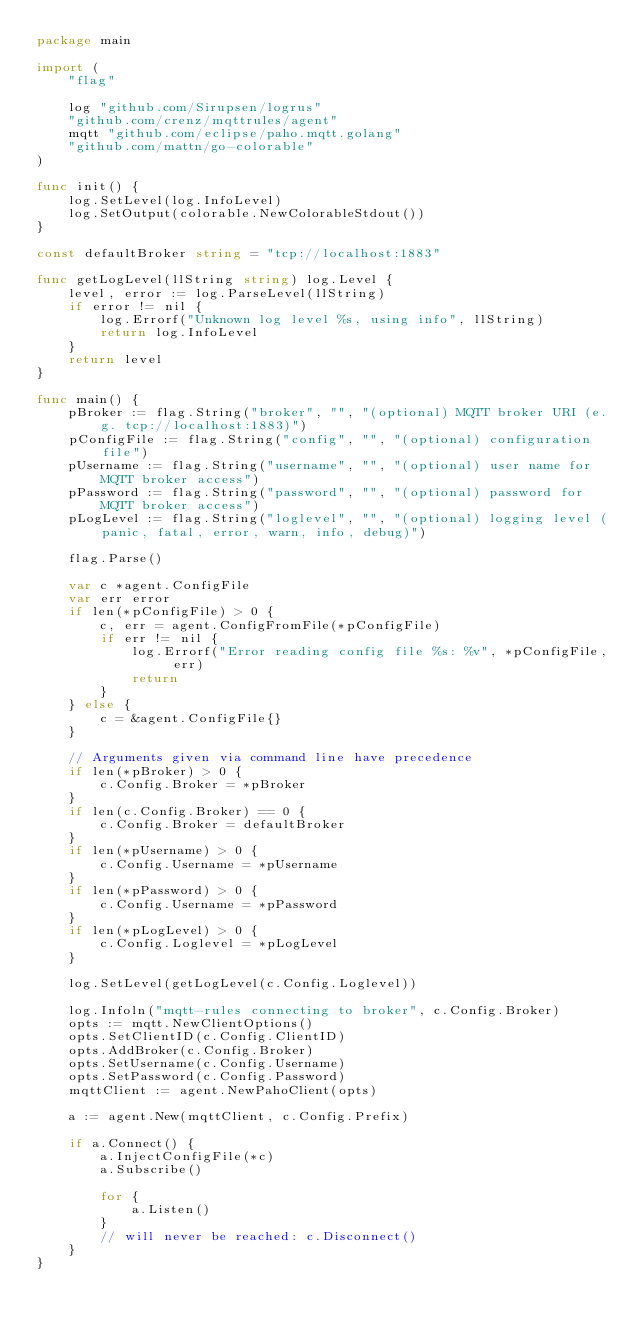<code> <loc_0><loc_0><loc_500><loc_500><_Go_>package main

import (
	"flag"

	log "github.com/Sirupsen/logrus"
	"github.com/crenz/mqttrules/agent"
	mqtt "github.com/eclipse/paho.mqtt.golang"
	"github.com/mattn/go-colorable"
)

func init() {
	log.SetLevel(log.InfoLevel)
	log.SetOutput(colorable.NewColorableStdout())
}

const defaultBroker string = "tcp://localhost:1883"

func getLogLevel(llString string) log.Level {
	level, error := log.ParseLevel(llString)
	if error != nil {
		log.Errorf("Unknown log level %s, using info", llString)
		return log.InfoLevel
	}
	return level
}

func main() {
	pBroker := flag.String("broker", "", "(optional) MQTT broker URI (e.g. tcp://localhost:1883)")
	pConfigFile := flag.String("config", "", "(optional) configuration file")
	pUsername := flag.String("username", "", "(optional) user name for MQTT broker access")
	pPassword := flag.String("password", "", "(optional) password for MQTT broker access")
	pLogLevel := flag.String("loglevel", "", "(optional) logging level (panic, fatal, error, warn, info, debug)")

	flag.Parse()

	var c *agent.ConfigFile
	var err error
	if len(*pConfigFile) > 0 {
		c, err = agent.ConfigFromFile(*pConfigFile)
		if err != nil {
			log.Errorf("Error reading config file %s: %v", *pConfigFile, err)
			return
		}
	} else {
		c = &agent.ConfigFile{}
	}

	// Arguments given via command line have precedence
	if len(*pBroker) > 0 {
		c.Config.Broker = *pBroker
	}
	if len(c.Config.Broker) == 0 {
		c.Config.Broker = defaultBroker
	}
	if len(*pUsername) > 0 {
		c.Config.Username = *pUsername
	}
	if len(*pPassword) > 0 {
		c.Config.Username = *pPassword
	}
	if len(*pLogLevel) > 0 {
		c.Config.Loglevel = *pLogLevel
	}

	log.SetLevel(getLogLevel(c.Config.Loglevel))

	log.Infoln("mqtt-rules connecting to broker", c.Config.Broker)
	opts := mqtt.NewClientOptions()
	opts.SetClientID(c.Config.ClientID)
	opts.AddBroker(c.Config.Broker)
	opts.SetUsername(c.Config.Username)
	opts.SetPassword(c.Config.Password)
	mqttClient := agent.NewPahoClient(opts)

	a := agent.New(mqttClient, c.Config.Prefix)

	if a.Connect() {
		a.InjectConfigFile(*c)
		a.Subscribe()

		for {
			a.Listen()
		}
		// will never be reached: c.Disconnect()
	}
}
</code> 